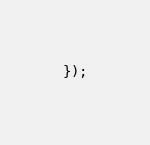Convert code to text. <code><loc_0><loc_0><loc_500><loc_500><_JavaScript_>});
</code> 